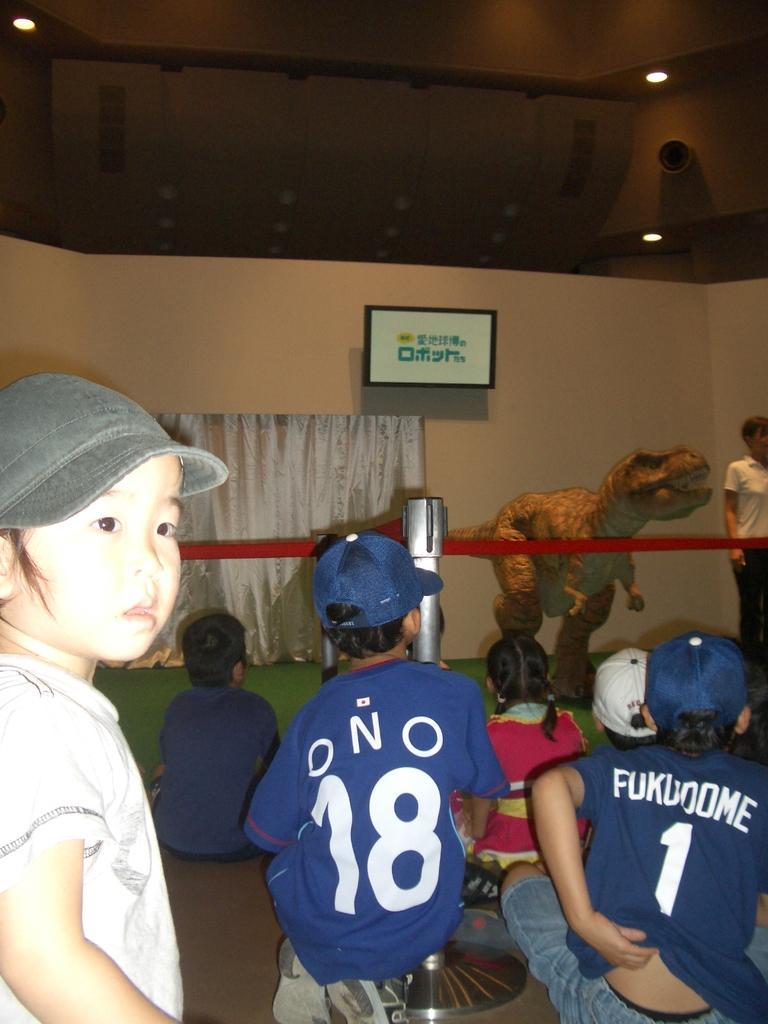Describe this image in one or two sentences. In this image there are kids with hats ,there is a rope barrier, a person standing , statue of a dinosaur , a curtain, board or a television attached to the wall, and there are lights. 